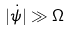Convert formula to latex. <formula><loc_0><loc_0><loc_500><loc_500>| \dot { \psi } | \gg \Omega</formula> 